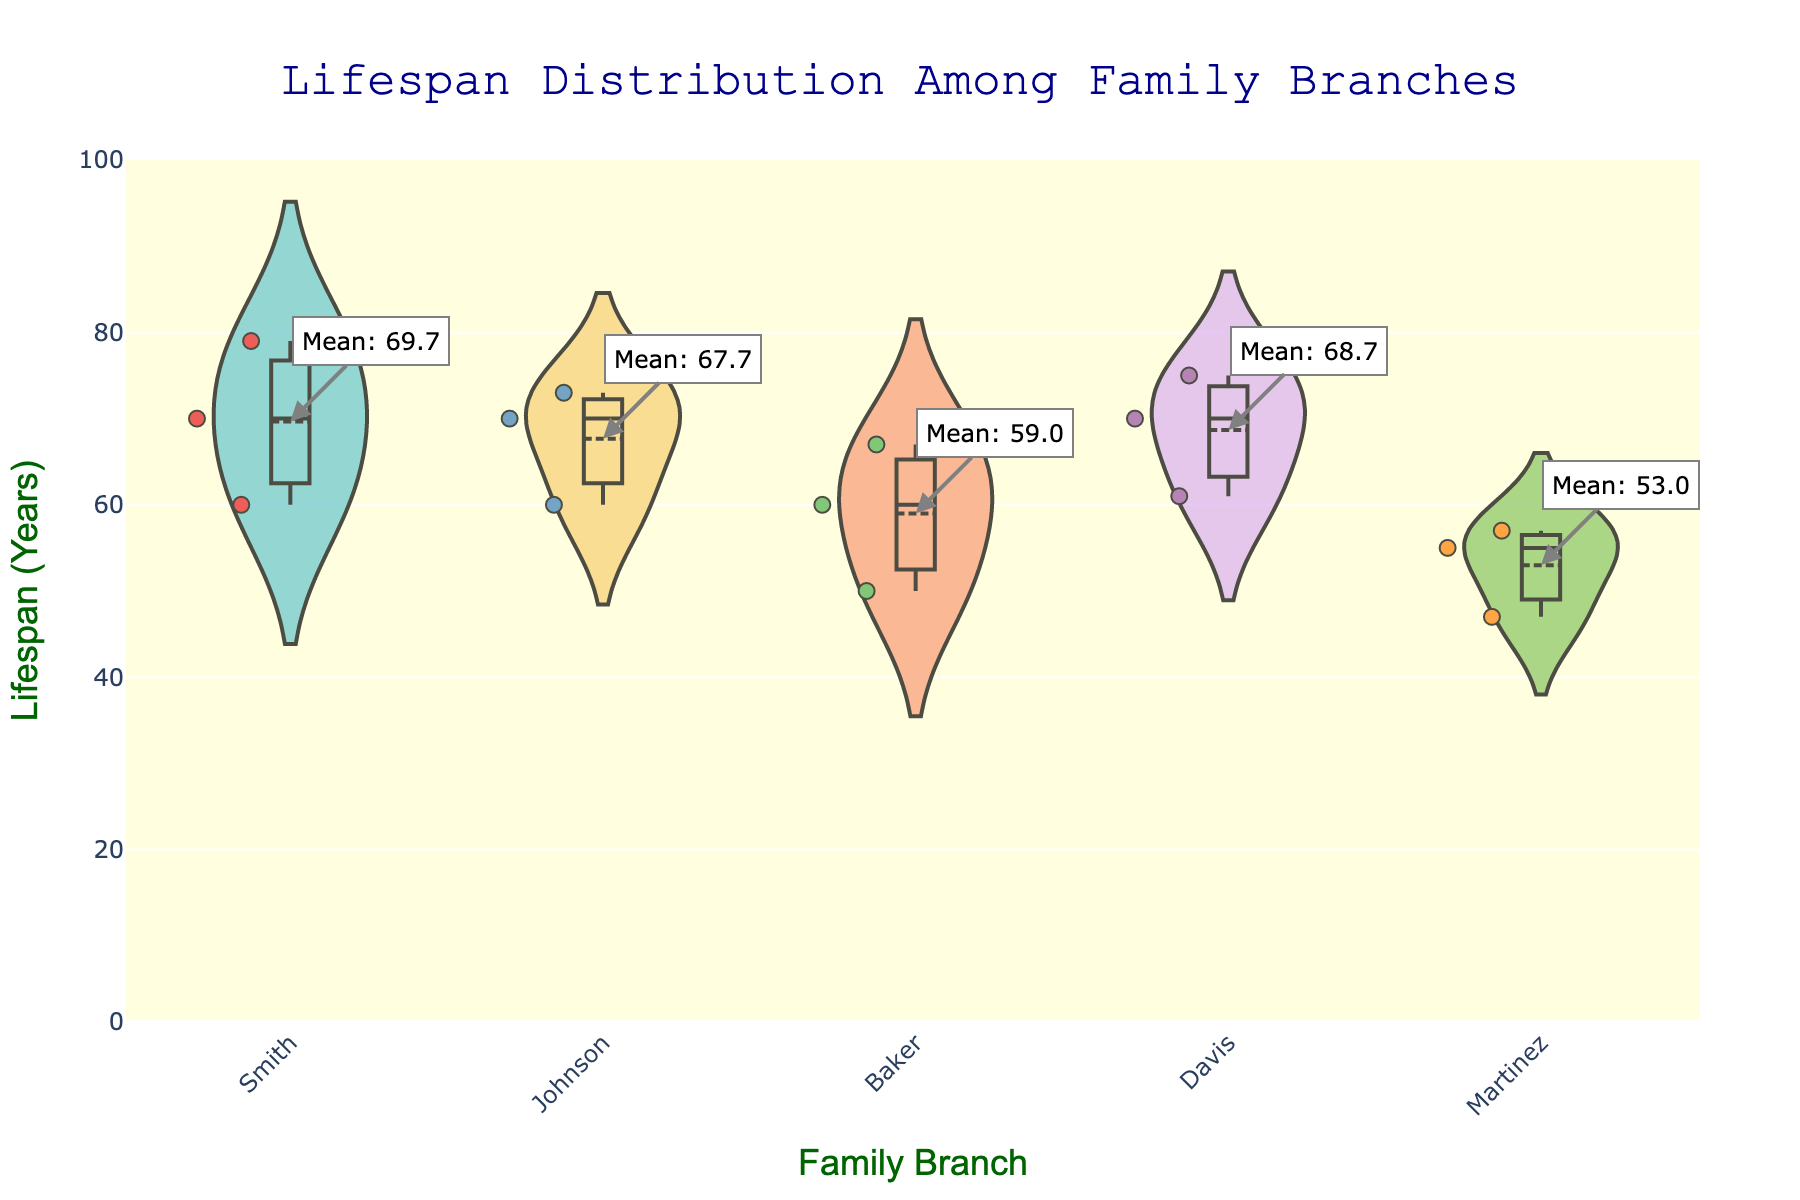What is the title of the plot? The title is usually placed at the top center of the figure and provides a brief description of what the figure represents.
Answer: Lifespan Distribution Among Family Branches How many family branches are represented in this plot? The number of family branches can be counted by looking at the unique labels on the x-axis.
Answer: Five What does the y-axis represent in this plot? The y-axis title provides information on what the vertical dimension of the plot measures.
Answer: Lifespan (Years) Which family branch has the longest average lifespan, according to the plot? The mean lifespans are provided by annotations on the figure. By comparing these annotations, we can identify the family branch with the longest average lifespan.
Answer: Davis What is the mean lifespan of the Johnson family branch? There is an annotation next to the violin for the Johnson branch indicating the mean lifespan.
Answer: 66.0 years Which family branch has the widest spread in recorded lifespans? The spread can be determined by examining the width of the violin plots, particularly where it is widest along the y-axis.
Answer: Davis How many members are included in the Baker family branch? The number of jittered points within the Baker category represents the number of data entries for this branch.
Answer: Three Which family branch has the smallest overlap between individual lifespans, indicating more consistency in lifespan? The violin plots that are narrower and less spread out indicate more consistency in the lifespans.
Answer: Smith Compare the lifespan range of the Smith and Martinez branches. Which branch has a higher minimum lifespan? By examining the lower end of the violin plots for both Smith and Martinez branches, we can compare the minimum lifespan represented.
Answer: Smith What is the difference in the mean lifespan between the Martinez and Johnson branches? We need to subtract the mean lifespan of the Johnson branch from the mean lifespan of the Martinez branch using the annotations provided.
Answer: -7.0 years (Martinez: 59.0 years, Johnson: 66.0 years) How many data points are there in total in the plot? Count the total number of jittered points across all family branches.
Answer: Fifteen 